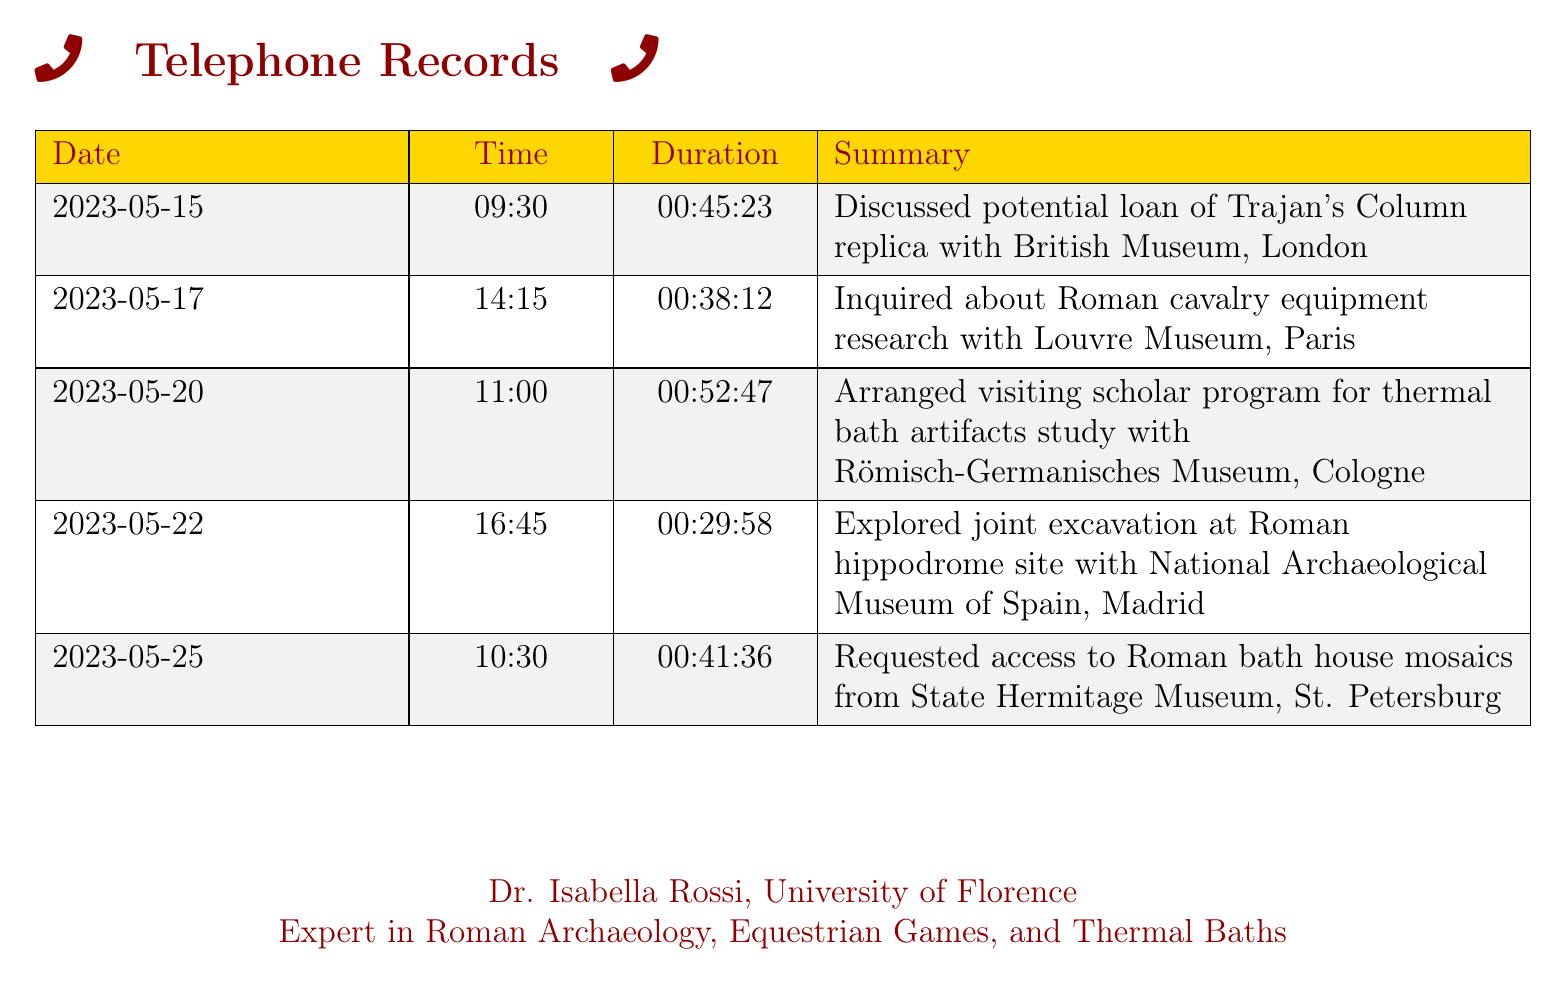What is the date of the call regarding Trajan's Column? This information is found in the call log, indicating the specific date when the discussion about Trajan's Column took place.
Answer: 2023-05-15 How long did the conversation with the Louvre Museum last? The duration of the call with the Louvre Museum is listed in the records, providing insight into the length of the inquiry.
Answer: 00:38:12 Which museum was contacted about Roman bath house mosaics? The summary of the relevant call indicates the specific museum involved in the request regarding Roman bath house mosaics.
Answer: State Hermitage Museum What was the main topic discussed during the call on May 20th? The summary for that date reveals the primary focus of the conversation related to thermal bath artifacts.
Answer: Visiting scholar program Which city is the Römisch-Germanisches Museum located in? The document includes the name of the museum, which allows us to determine its location.
Answer: Cologne What was arranged with the National Archaeological Museum of Spain? An overview of the interaction with the museum reveals a collaborative aspect suggested in the conversation.
Answer: Joint excavation Who is the expert mentioned in the telephone records? The document closes with an identification of the expert connected to the archaeological discussions, providing a name.
Answer: Dr. Isabella Rossi How many calls were made to museums in May? The records show entries from May, each of which indicates a conversation with a museum during that month.
Answer: Five What time did the call on May 25th take place? The specific time of the call on this day is recorded in the call log, identifying when the inquiry occurred.
Answer: 10:30 